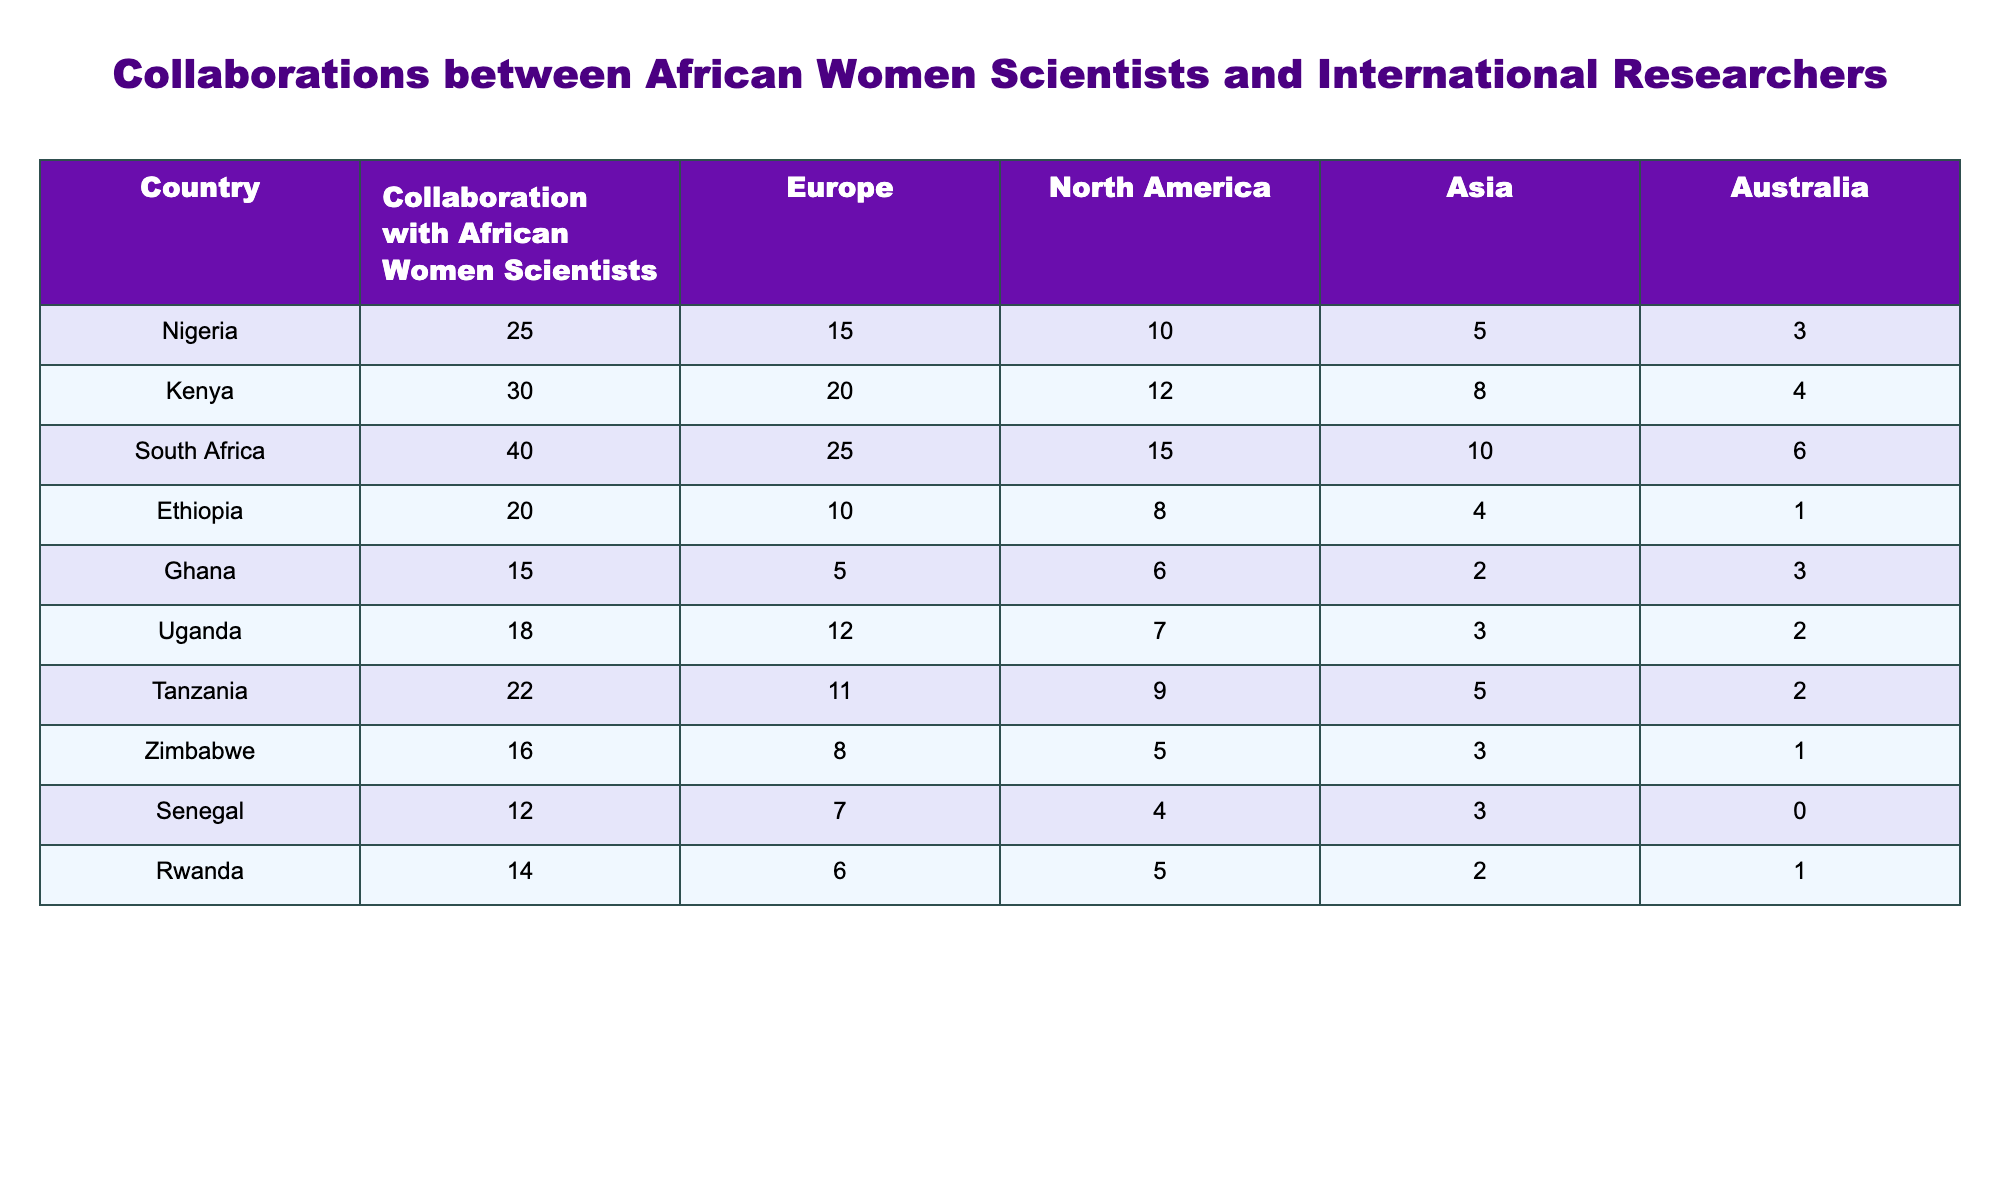What is the highest collaboration number reported in the table? By scanning through the collaboration numbers for each country, South Africa has the highest collaboration number with a total of 40.
Answer: 40 Which country has the least collaboration with African women scientists? Looking at the first column, Ghana has the least collaboration number, which is 15.
Answer: 15 What is the total number of collaborations for Kenya with international researchers? The total collaboration for Kenya (30) includes collaborations with Europe (20), North America (12), Asia (8), and Australia (4): 20 + 12 + 8 + 4 = 44.
Answer: 44 Are there any countries with zero collaboration with international researchers in Australia? Checking the Australia column, Senegal has zero collaborations, hence the answer is yes; there is at least one country with no collaborations in Australia.
Answer: Yes What is the average collaboration number across all listed countries? To find the average, I sum all collaboration values (total = 25 + 30 + 40 + 20 + 15 + 18 + 22 + 16 + 12 + 14 =  252) and divide by the number of countries (10): 252/10 = 25.2.
Answer: 25.2 Which continent shows the highest collaboration for Nigeria? By checking Nigeria's numbers against each continent, Europe shows the highest collaboration number (15) compared to North America (10), Asia (5), and Australia (3).
Answer: Europe If we sum the number of collaborations for all countries with over 20 collaborations, what is the total? The countries with over 20 collaborations are Nigeria (25), Kenya (30), South Africa (40), Uganda (18), and Tanzania (22). Summing those gives: 25 + 30 + 40 + 22 = 117.
Answer: 117 Is there a pattern in collaboration with international researchers across the countries based on their collaboration numbers? Analyzing the table, higher collaboration numbers tend to be associated with southern African countries like South Africa and Kenya, while countries like Senegal and Rwanda show much lower collaboration levels.
Answer: Yes What is the total number of collaborations specifically from Senegal with international researchers? The total number of collaborations for Senegal is the sum of the values across all columns, which adds up as follows for Senegal: Europe (7), North America (4), Asia (3), and Australia (0) = 7 + 4 + 3 + 0 = 14.
Answer: 14 